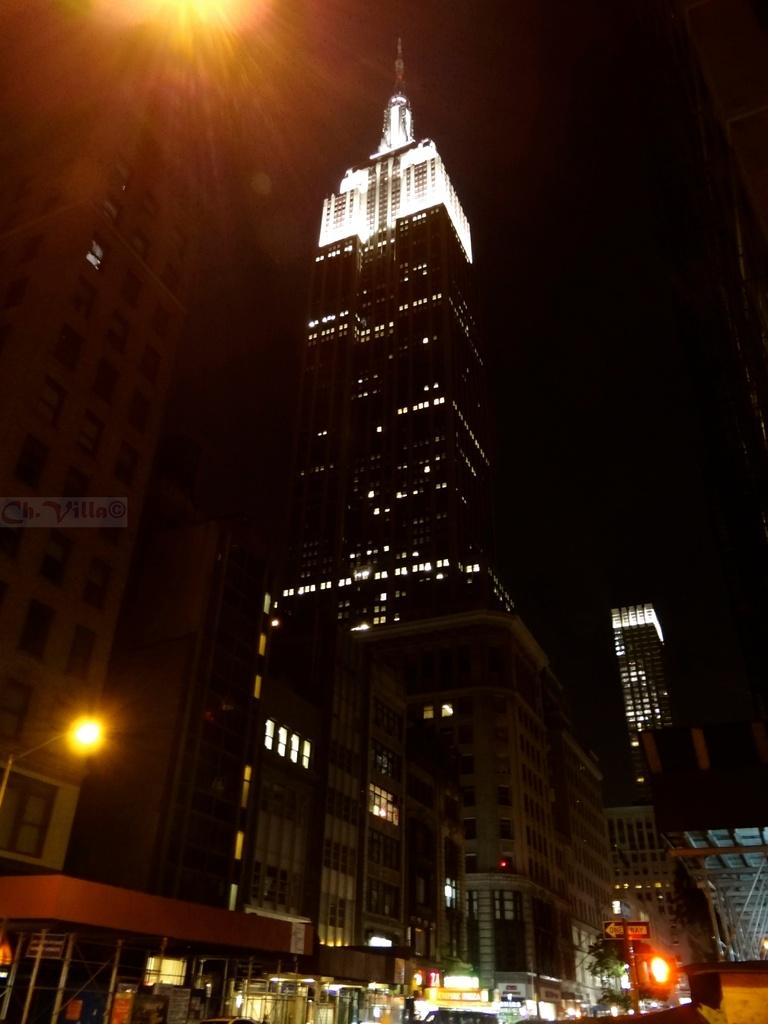What type of structures can be seen in the image? There are buildings in the image. What else is visible in the image besides the buildings? There are lights, a sign board, and a pole visible in the image. What is the color of the background in the image? The background of the image is dark. What type of coach can be seen in the image? There is no coach present in the image. Are there any ants visible in the image? There are no ants visible in the image. 